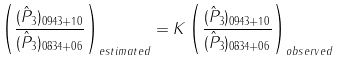<formula> <loc_0><loc_0><loc_500><loc_500>\left ( \frac { ( { \hat { P } _ { 3 } } ) _ { 0 9 4 3 + 1 0 } } { ( { \hat { P } _ { 3 } } ) _ { 0 8 3 4 + 0 6 } } \right ) _ { e s t i m a t e d } = K \left ( \frac { ( { \hat { P } _ { 3 } } ) _ { 0 9 4 3 + 1 0 } } { ( { \hat { P } _ { 3 } } ) _ { 0 8 3 4 + 0 6 } } \right ) _ { o b s e r v e d }</formula> 